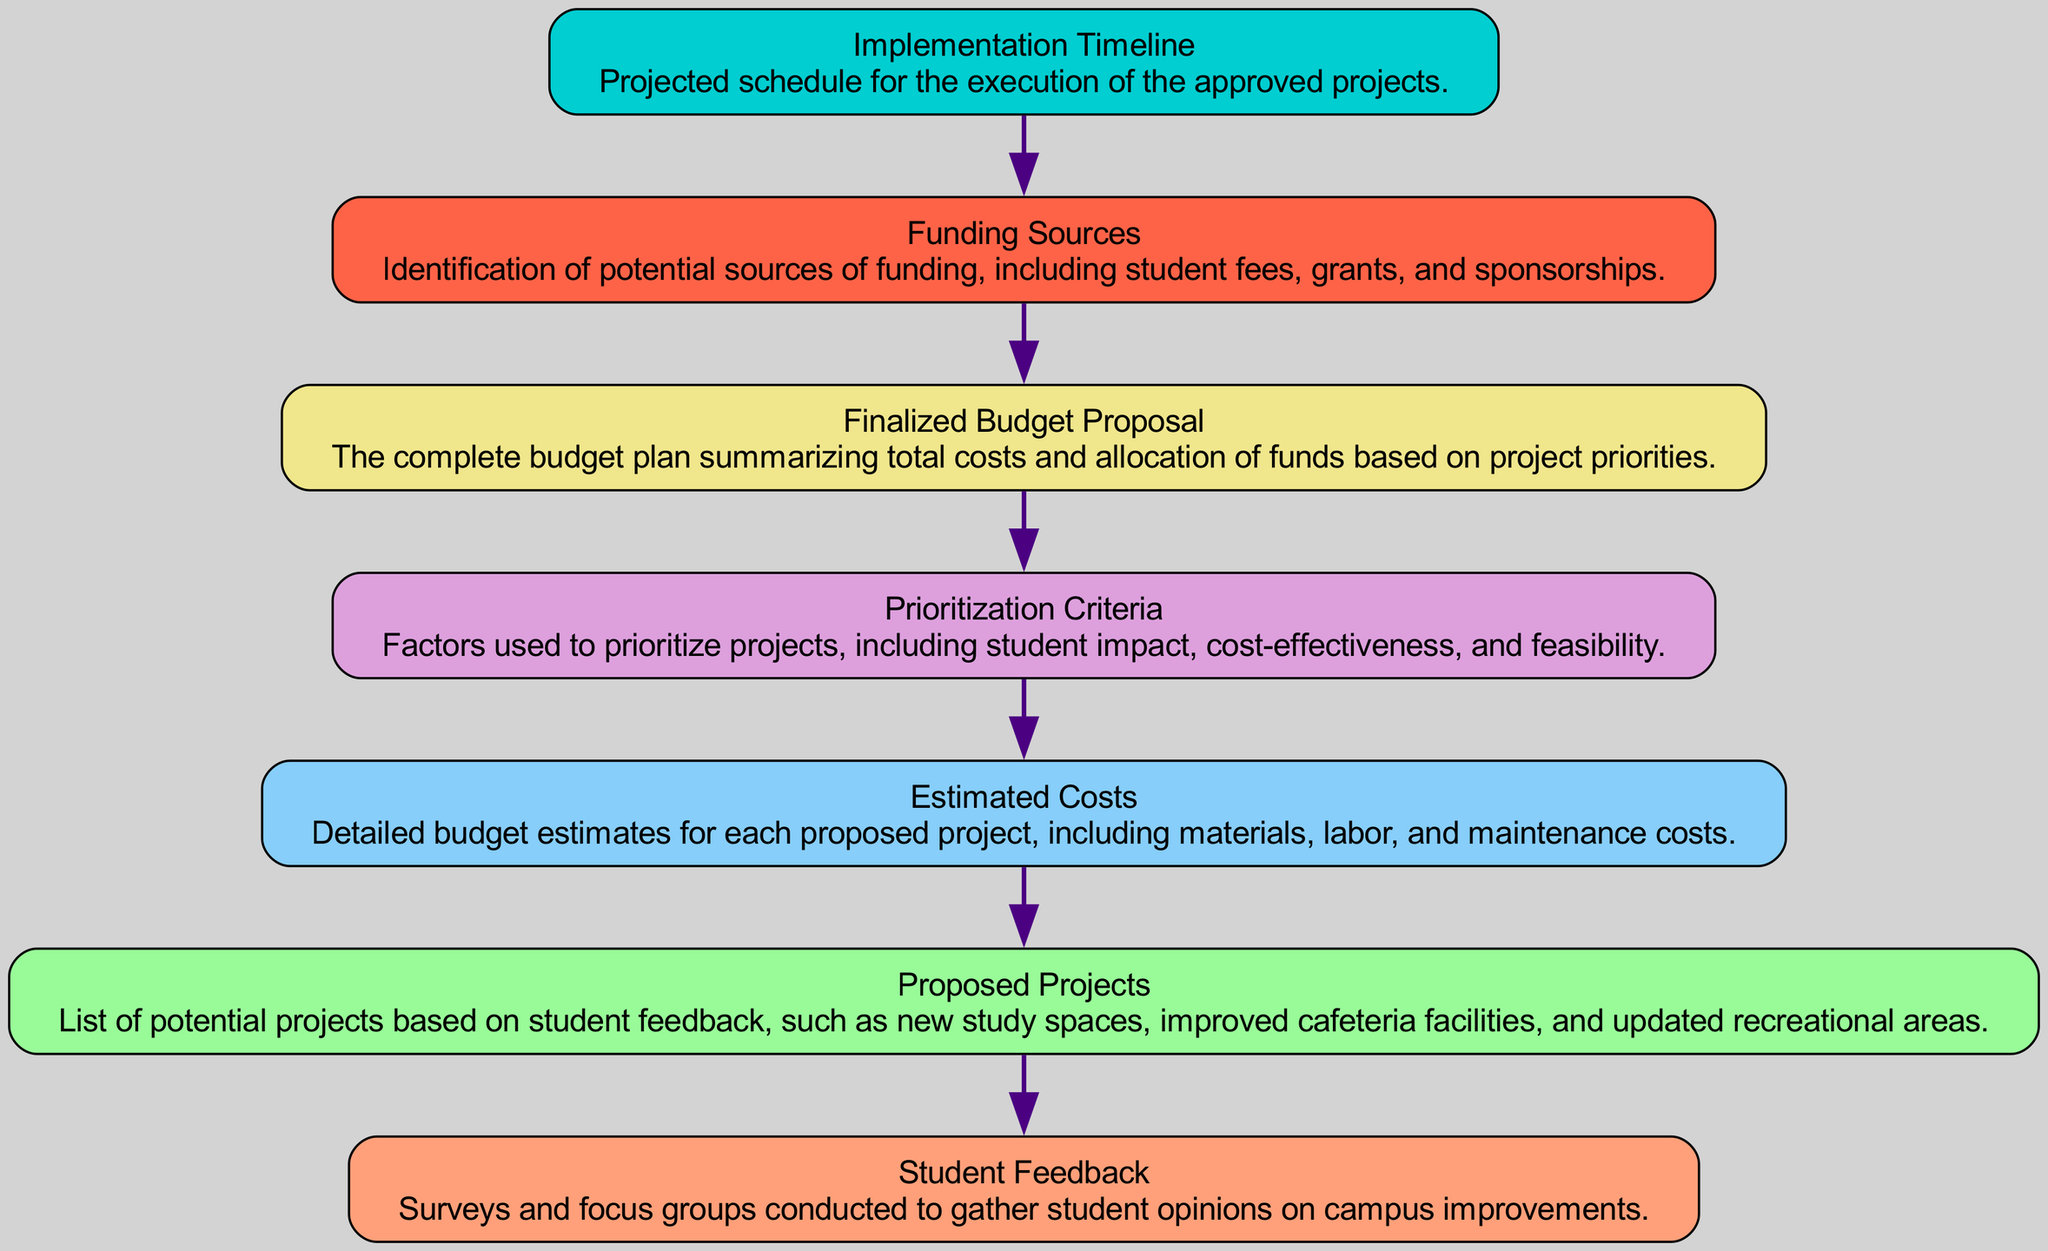What is the first node in the diagram? The first node is "Student Feedback," which represents the initial step in the flow of the diagram.
Answer: Student Feedback How many nodes are there in total? Counting from "Student Feedback" to "Implementation Timeline," there are seven nodes in the diagram.
Answer: Seven What node follows "Estimated Costs"? The node that follows "Estimated Costs" is "Prioritization Criteria," indicating the next step after cost estimation.
Answer: Prioritization Criteria Which node is concerned with funding? The "Funding Sources" node identifies potential funding options for the proposed projects based on student feedback.
Answer: Funding Sources What does the "Finalized Budget Proposal" node summarize? The "Finalized Budget Proposal" node summarizes the total costs and allocation of funds for the projects, indicating the overall budget plan.
Answer: Total costs and allocation of funds How are projects prioritized according to the diagram? Projects are prioritized based on "Prioritization Criteria," which considers factors such as student impact, cost-effectiveness, and feasibility.
Answer: Factors like student impact, cost-effectiveness, and feasibility Which node should be consulted for a timeline of project execution? The "Implementation Timeline" node provides the projected schedule for executing the approved projects, detailing when they will start and end.
Answer: Implementation Timeline What is the role of "Proposed Projects" in this diagram? "Proposed Projects" represent the list of potential initiatives that incorporate student feedback, setting the stage for budget estimation and prioritization.
Answer: List of potential initiatives Why is "Funding Sources" placed before "Finalized Budget Proposal"? "Funding Sources" must be identified first to inform and shape the "Finalized Budget Proposal," ensuring that the budget reflects available funding.
Answer: To inform and shape the budget 